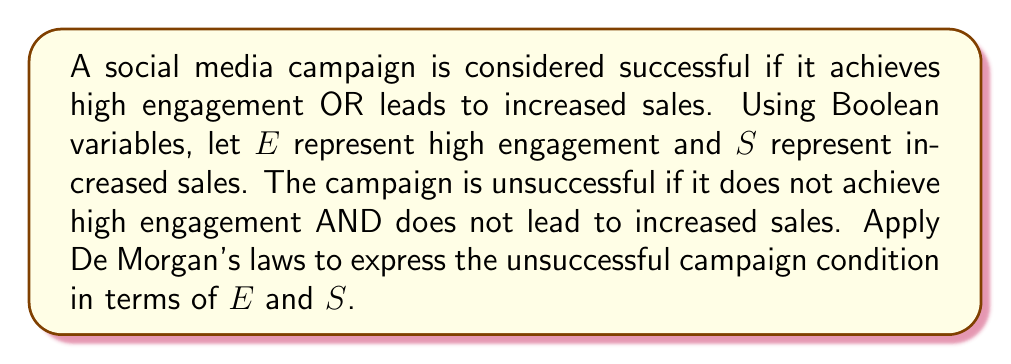Can you answer this question? Let's approach this step-by-step:

1) First, we define the success condition in Boolean terms:
   Success = $E \lor S$

2) The unsuccessful condition is the negation of success:
   Unsuccessful = $\neg(E \lor S)$

3) Now, we apply De Morgan's law to this negation. De Morgan's law states that:
   $\neg(A \lor B) = \neg A \land \neg B$

4) Applying this to our expression:
   $\neg(E \lor S) = \neg E \land \neg S$

5) This can be interpreted as: The campaign is unsuccessful if it does not achieve high engagement AND does not lead to increased sales.

6) In terms of measurement, this means we need to track both engagement metrics and sales figures. If both are low, the campaign is unsuccessful.
Answer: $\neg E \land \neg S$ 